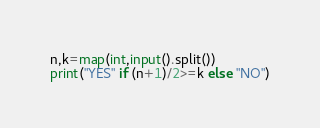<code> <loc_0><loc_0><loc_500><loc_500><_Python_>n,k=map(int,input().split())
print("YES" if (n+1)/2>=k else "NO")
</code> 